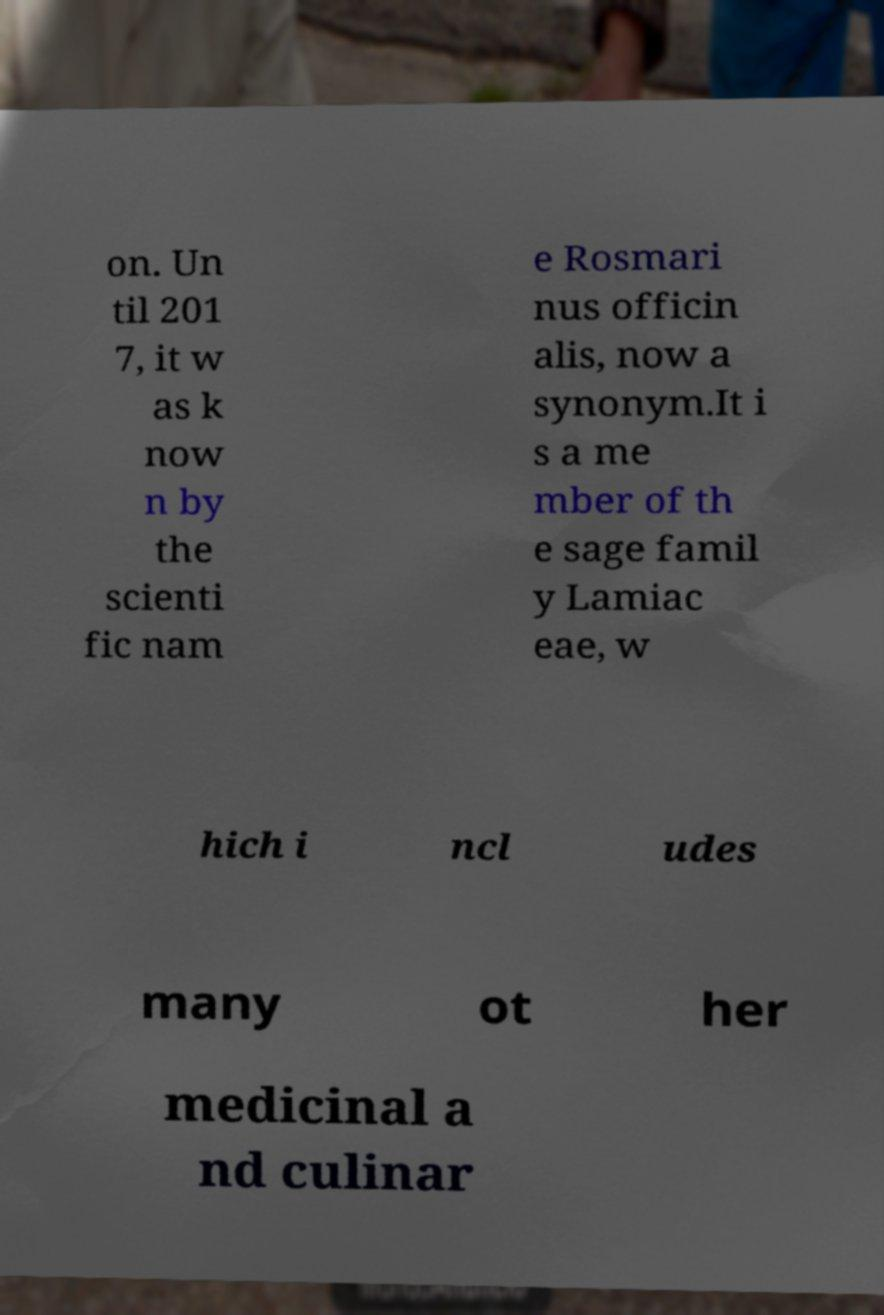Please identify and transcribe the text found in this image. on. Un til 201 7, it w as k now n by the scienti fic nam e Rosmari nus officin alis, now a synonym.It i s a me mber of th e sage famil y Lamiac eae, w hich i ncl udes many ot her medicinal a nd culinar 